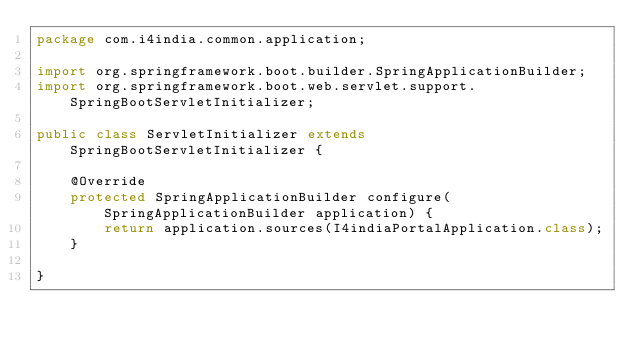<code> <loc_0><loc_0><loc_500><loc_500><_Java_>package com.i4india.common.application;

import org.springframework.boot.builder.SpringApplicationBuilder;
import org.springframework.boot.web.servlet.support.SpringBootServletInitializer;

public class ServletInitializer extends SpringBootServletInitializer {

	@Override
	protected SpringApplicationBuilder configure(SpringApplicationBuilder application) {
		return application.sources(I4indiaPortalApplication.class);
	}

}
</code> 